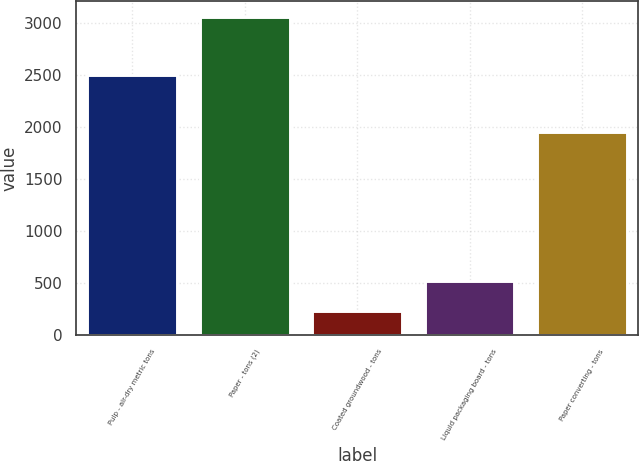Convert chart. <chart><loc_0><loc_0><loc_500><loc_500><bar_chart><fcel>Pulp - air-dry metric tons<fcel>Paper - tons (2)<fcel>Coated groundwood - tons<fcel>Liquid packaging board - tons<fcel>Paper converting - tons<nl><fcel>2502<fcel>3060<fcel>234<fcel>516.6<fcel>1950<nl></chart> 